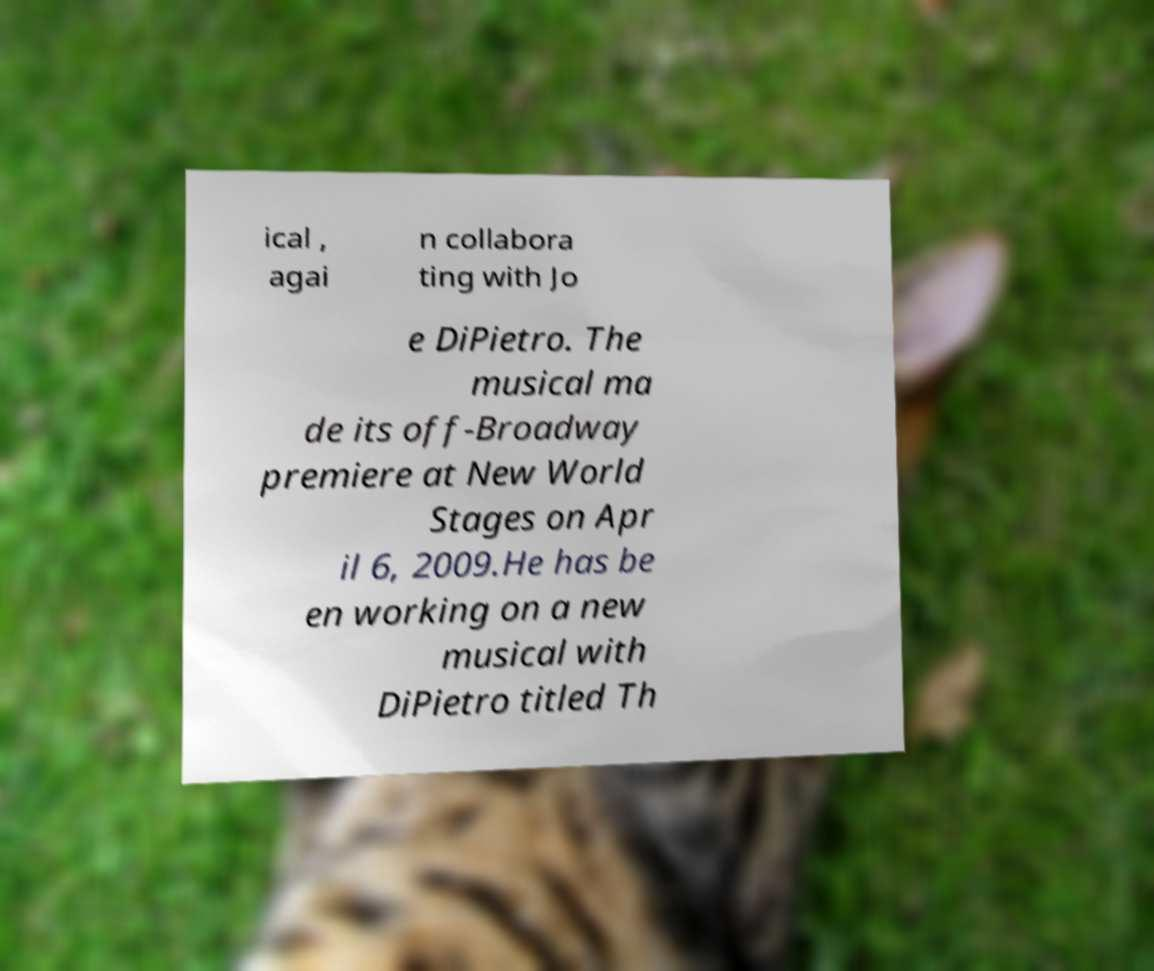Can you read and provide the text displayed in the image?This photo seems to have some interesting text. Can you extract and type it out for me? ical , agai n collabora ting with Jo e DiPietro. The musical ma de its off-Broadway premiere at New World Stages on Apr il 6, 2009.He has be en working on a new musical with DiPietro titled Th 